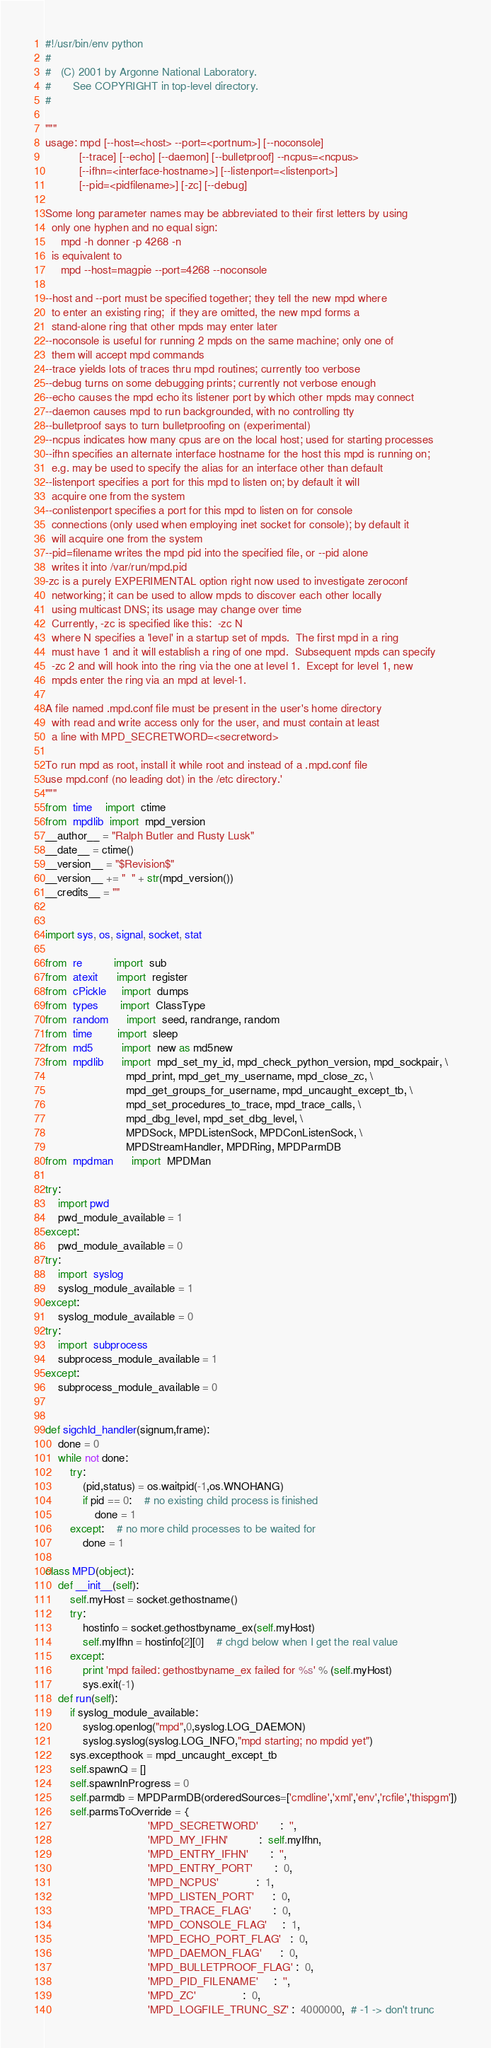Convert code to text. <code><loc_0><loc_0><loc_500><loc_500><_Python_>#!/usr/bin/env python
#
#   (C) 2001 by Argonne National Laboratory.
#       See COPYRIGHT in top-level directory.
#

"""
usage: mpd [--host=<host> --port=<portnum>] [--noconsole]
           [--trace] [--echo] [--daemon] [--bulletproof] --ncpus=<ncpus>
           [--ifhn=<interface-hostname>] [--listenport=<listenport>]
           [--pid=<pidfilename>] [-zc] [--debug]

Some long parameter names may be abbreviated to their first letters by using
  only one hyphen and no equal sign:
     mpd -h donner -p 4268 -n
  is equivalent to
     mpd --host=magpie --port=4268 --noconsole

--host and --port must be specified together; they tell the new mpd where
  to enter an existing ring;  if they are omitted, the new mpd forms a
  stand-alone ring that other mpds may enter later
--noconsole is useful for running 2 mpds on the same machine; only one of
  them will accept mpd commands
--trace yields lots of traces thru mpd routines; currently too verbose
--debug turns on some debugging prints; currently not verbose enough
--echo causes the mpd echo its listener port by which other mpds may connect
--daemon causes mpd to run backgrounded, with no controlling tty
--bulletproof says to turn bulletproofing on (experimental)
--ncpus indicates how many cpus are on the local host; used for starting processes
--ifhn specifies an alternate interface hostname for the host this mpd is running on;
  e.g. may be used to specify the alias for an interface other than default
--listenport specifies a port for this mpd to listen on; by default it will
  acquire one from the system
--conlistenport specifies a port for this mpd to listen on for console
  connections (only used when employing inet socket for console); by default it
  will acquire one from the system
--pid=filename writes the mpd pid into the specified file, or --pid alone
  writes it into /var/run/mpd.pid
-zc is a purely EXPERIMENTAL option right now used to investigate zeroconf
  networking; it can be used to allow mpds to discover each other locally
  using multicast DNS; its usage may change over time
  Currently, -zc is specified like this:  -zc N
  where N specifies a 'level' in a startup set of mpds.  The first mpd in a ring
  must have 1 and it will establish a ring of one mpd.  Subsequent mpds can specify
  -zc 2 and will hook into the ring via the one at level 1.  Except for level 1, new
  mpds enter the ring via an mpd at level-1.

A file named .mpd.conf file must be present in the user's home directory
  with read and write access only for the user, and must contain at least
  a line with MPD_SECRETWORD=<secretword>

To run mpd as root, install it while root and instead of a .mpd.conf file
use mpd.conf (no leading dot) in the /etc directory.' 
"""
from  time    import  ctime
from  mpdlib  import  mpd_version
__author__ = "Ralph Butler and Rusty Lusk"
__date__ = ctime()
__version__ = "$Revision$"
__version__ += "  " + str(mpd_version())
__credits__ = ""


import sys, os, signal, socket, stat

from  re          import  sub
from  atexit      import  register
from  cPickle     import  dumps
from  types       import  ClassType
from  random      import  seed, randrange, random
from  time        import  sleep
from  md5         import  new as md5new
from  mpdlib      import  mpd_set_my_id, mpd_check_python_version, mpd_sockpair, \
                          mpd_print, mpd_get_my_username, mpd_close_zc, \
                          mpd_get_groups_for_username, mpd_uncaught_except_tb, \
                          mpd_set_procedures_to_trace, mpd_trace_calls, \
                          mpd_dbg_level, mpd_set_dbg_level, \
                          MPDSock, MPDListenSock, MPDConListenSock, \
                          MPDStreamHandler, MPDRing, MPDParmDB
from  mpdman      import  MPDMan

try:
    import pwd
    pwd_module_available = 1
except:
    pwd_module_available = 0
try:
    import  syslog
    syslog_module_available = 1
except:
    syslog_module_available = 0
try:
    import  subprocess
    subprocess_module_available = 1
except:
    subprocess_module_available = 0


def sigchld_handler(signum,frame):
    done = 0
    while not done:
        try:
            (pid,status) = os.waitpid(-1,os.WNOHANG)
            if pid == 0:    # no existing child process is finished
                done = 1
        except:    # no more child processes to be waited for
            done = 1
            
class MPD(object):
    def __init__(self):
        self.myHost = socket.gethostname()
        try:
            hostinfo = socket.gethostbyname_ex(self.myHost)
            self.myIfhn = hostinfo[2][0]    # chgd below when I get the real value
        except:
            print 'mpd failed: gethostbyname_ex failed for %s' % (self.myHost)
            sys.exit(-1)
    def run(self):
        if syslog_module_available:
            syslog.openlog("mpd",0,syslog.LOG_DAEMON)
            syslog.syslog(syslog.LOG_INFO,"mpd starting; no mpdid yet")
        sys.excepthook = mpd_uncaught_except_tb
        self.spawnQ = []
        self.spawnInProgress = 0
        self.parmdb = MPDParmDB(orderedSources=['cmdline','xml','env','rcfile','thispgm'])
        self.parmsToOverride = {
                                 'MPD_SECRETWORD'       :  '',
                                 'MPD_MY_IFHN'          :  self.myIfhn,
                                 'MPD_ENTRY_IFHN'       :  '',
                                 'MPD_ENTRY_PORT'       :  0,
                                 'MPD_NCPUS'            :  1,
                                 'MPD_LISTEN_PORT'      :  0,
                                 'MPD_TRACE_FLAG'       :  0,
                                 'MPD_CONSOLE_FLAG'     :  1,
                                 'MPD_ECHO_PORT_FLAG'   :  0,
                                 'MPD_DAEMON_FLAG'      :  0,
                                 'MPD_BULLETPROOF_FLAG' :  0,
                                 'MPD_PID_FILENAME'     :  '',
                                 'MPD_ZC'               :  0,
                                 'MPD_LOGFILE_TRUNC_SZ' :  4000000,  # -1 -> don't trunc</code> 